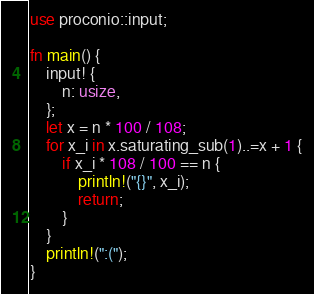<code> <loc_0><loc_0><loc_500><loc_500><_Rust_>use proconio::input;

fn main() {
    input! {
        n: usize,
    };
    let x = n * 100 / 108;
    for x_i in x.saturating_sub(1)..=x + 1 {
        if x_i * 108 / 100 == n {
            println!("{}", x_i);
            return;
        }
    }
    println!(":(");
}
</code> 